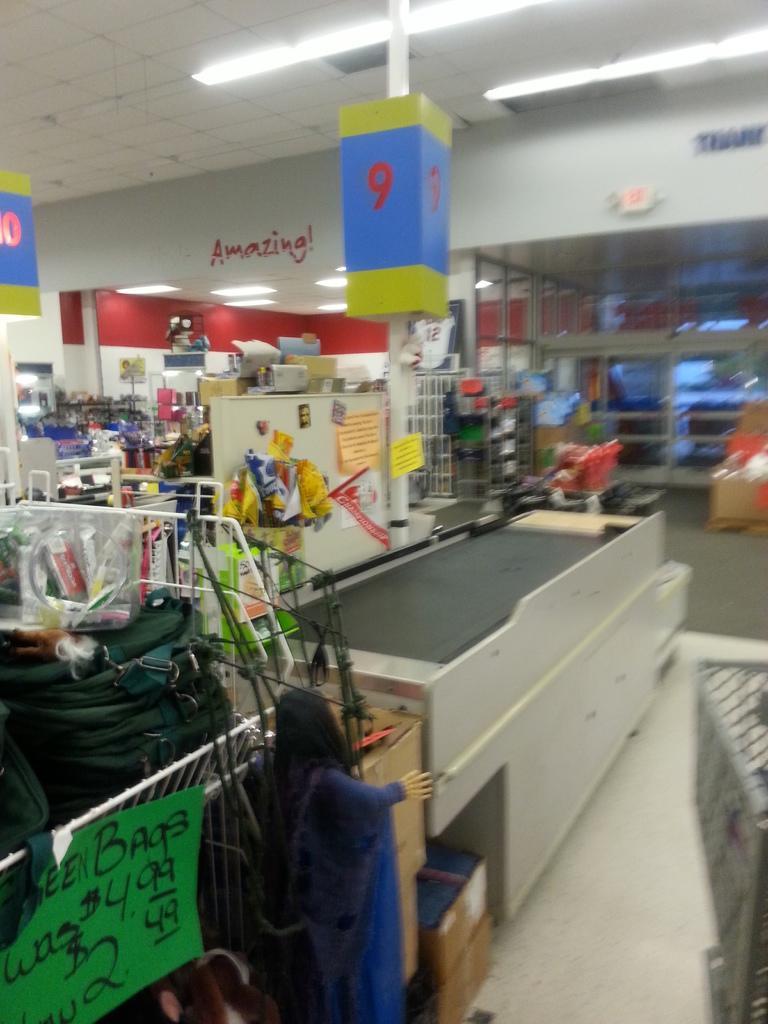In one or two sentences, can you explain what this image depicts? This picture describes about inside view of a mall, in this we can find some carts, hoardings and lights, and also we can see some other things. 